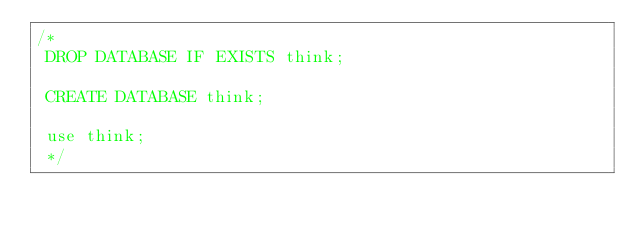<code> <loc_0><loc_0><loc_500><loc_500><_SQL_>/*
 DROP DATABASE IF EXISTS think;
 
 CREATE DATABASE think;
 
 use think;
 */</code> 